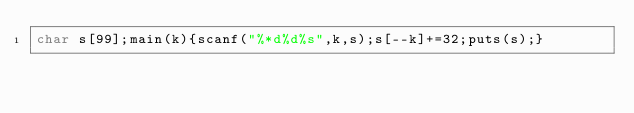Convert code to text. <code><loc_0><loc_0><loc_500><loc_500><_C_>char s[99];main(k){scanf("%*d%d%s",k,s);s[--k]+=32;puts(s);}</code> 